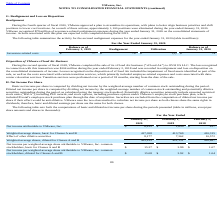From Vmware's financial document, Which years does the table provide information for the computations of basic and diluted net income per share? The document contains multiple relevant values: 2020, 2019, 2018. From the document: "February 1, 2019 Realignment Utilization During the fourth quarter of fiscal 2020, VMware approved a plan to streamline its operations, with plans to ..." Also, What was the Net income attributable to VMware, Inc. in 2018? According to the financial document, 437 (in millions). The relevant text states: "me attributable to VMware, Inc. $ 6,412 $ 1,650 $ 437..." Also, What was the Weighted-average shares, basic for Classes A and B in 2019? According to the financial document, 413,769 (in thousands). The relevant text states: "average shares, basic for Classes A and B 417,058 413,769 410,315..." Also, can you calculate: What was the change in the Effect of other dilutive securities between 2018 and 2019? Based on the calculation: 7,362-10,572, the result is -3210 (in millions). This is based on the information: "Effect of other dilutive securities 8,177 7,362 10,572 Effect of other dilutive securities 8,177 7,362 10,572..." The key data points involved are: 10,572, 7,362. Also, How many years did the Weighted-average shares, basic for Classes A and B exceed $400,000 million? Counting the relevant items in the document: 2020, 2019, 2018, I find 3 instances. The key data points involved are: 2018, 2019, 2020. Also, can you calculate: What was the percentage change in the Net income attributable to VMware, Inc. between 2019 and 2020? To answer this question, I need to perform calculations using the financial data. The calculation is: (6,412-1,650)/1,650, which equals 288.61 (percentage). This is based on the information: "Net income attributable to VMware, Inc. $ 6,412 $ 1,650 $ 437 Net income attributable to VMware, Inc. $ 6,412 $ 1,650 $ 437..." The key data points involved are: 1,650, 6,412. 